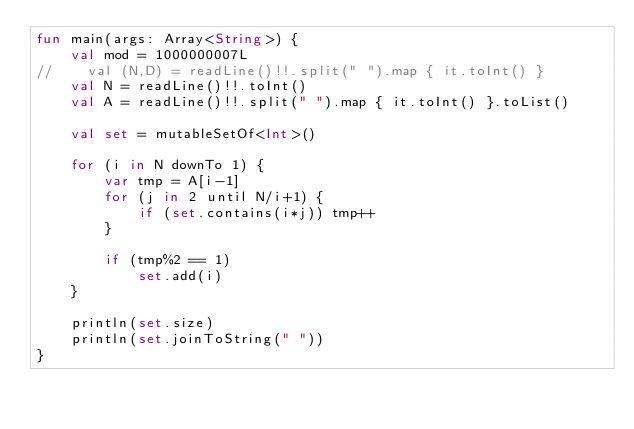Convert code to text. <code><loc_0><loc_0><loc_500><loc_500><_Kotlin_>fun main(args: Array<String>) {
    val mod = 1000000007L
//    val (N,D) = readLine()!!.split(" ").map { it.toInt() }
    val N = readLine()!!.toInt()
    val A = readLine()!!.split(" ").map { it.toInt() }.toList()

    val set = mutableSetOf<Int>()

    for (i in N downTo 1) {
        var tmp = A[i-1]
        for (j in 2 until N/i+1) {
            if (set.contains(i*j)) tmp++
        }

        if (tmp%2 == 1)
            set.add(i)
    }

    println(set.size)
    println(set.joinToString(" "))
}

</code> 